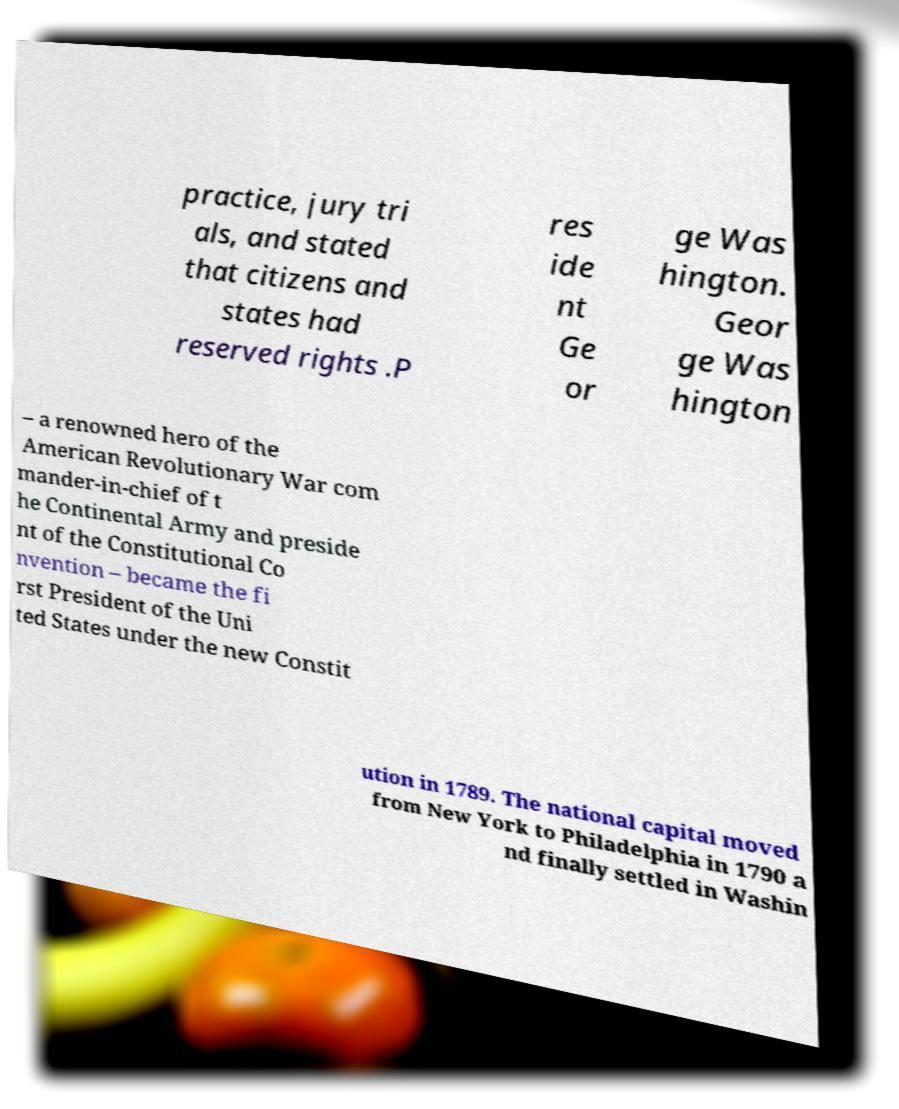Can you read and provide the text displayed in the image?This photo seems to have some interesting text. Can you extract and type it out for me? practice, jury tri als, and stated that citizens and states had reserved rights .P res ide nt Ge or ge Was hington. Geor ge Was hington – a renowned hero of the American Revolutionary War com mander-in-chief of t he Continental Army and preside nt of the Constitutional Co nvention – became the fi rst President of the Uni ted States under the new Constit ution in 1789. The national capital moved from New York to Philadelphia in 1790 a nd finally settled in Washin 